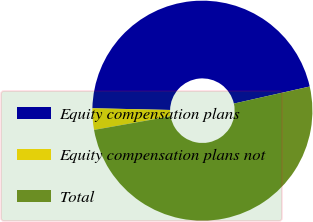Convert chart. <chart><loc_0><loc_0><loc_500><loc_500><pie_chart><fcel>Equity compensation plans<fcel>Equity compensation plans not<fcel>Total<nl><fcel>46.12%<fcel>3.15%<fcel>50.73%<nl></chart> 